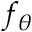Convert formula to latex. <formula><loc_0><loc_0><loc_500><loc_500>f _ { \theta }</formula> 